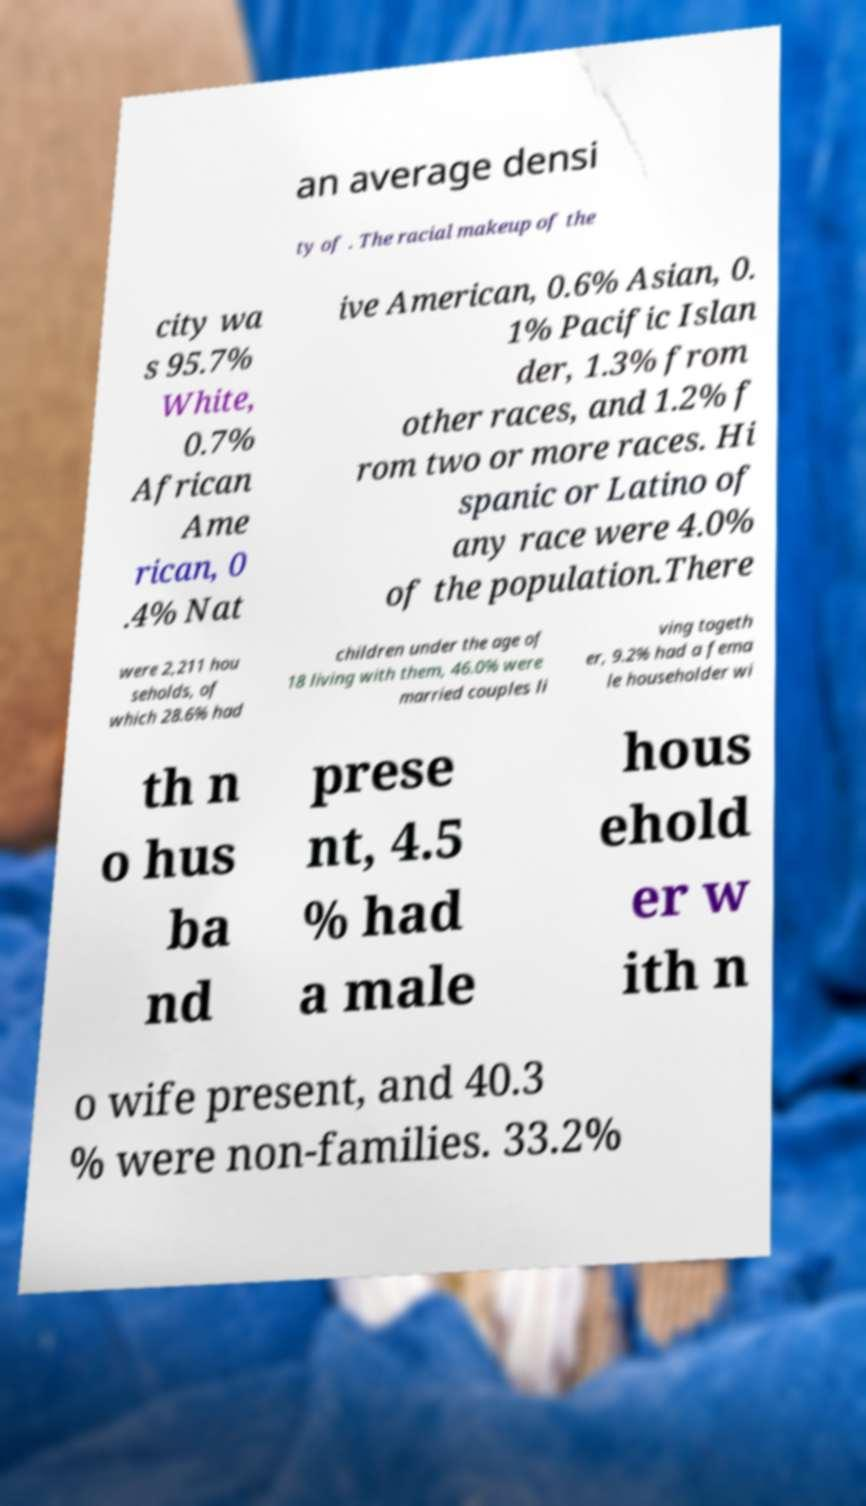Could you assist in decoding the text presented in this image and type it out clearly? an average densi ty of . The racial makeup of the city wa s 95.7% White, 0.7% African Ame rican, 0 .4% Nat ive American, 0.6% Asian, 0. 1% Pacific Islan der, 1.3% from other races, and 1.2% f rom two or more races. Hi spanic or Latino of any race were 4.0% of the population.There were 2,211 hou seholds, of which 28.6% had children under the age of 18 living with them, 46.0% were married couples li ving togeth er, 9.2% had a fema le householder wi th n o hus ba nd prese nt, 4.5 % had a male hous ehold er w ith n o wife present, and 40.3 % were non-families. 33.2% 